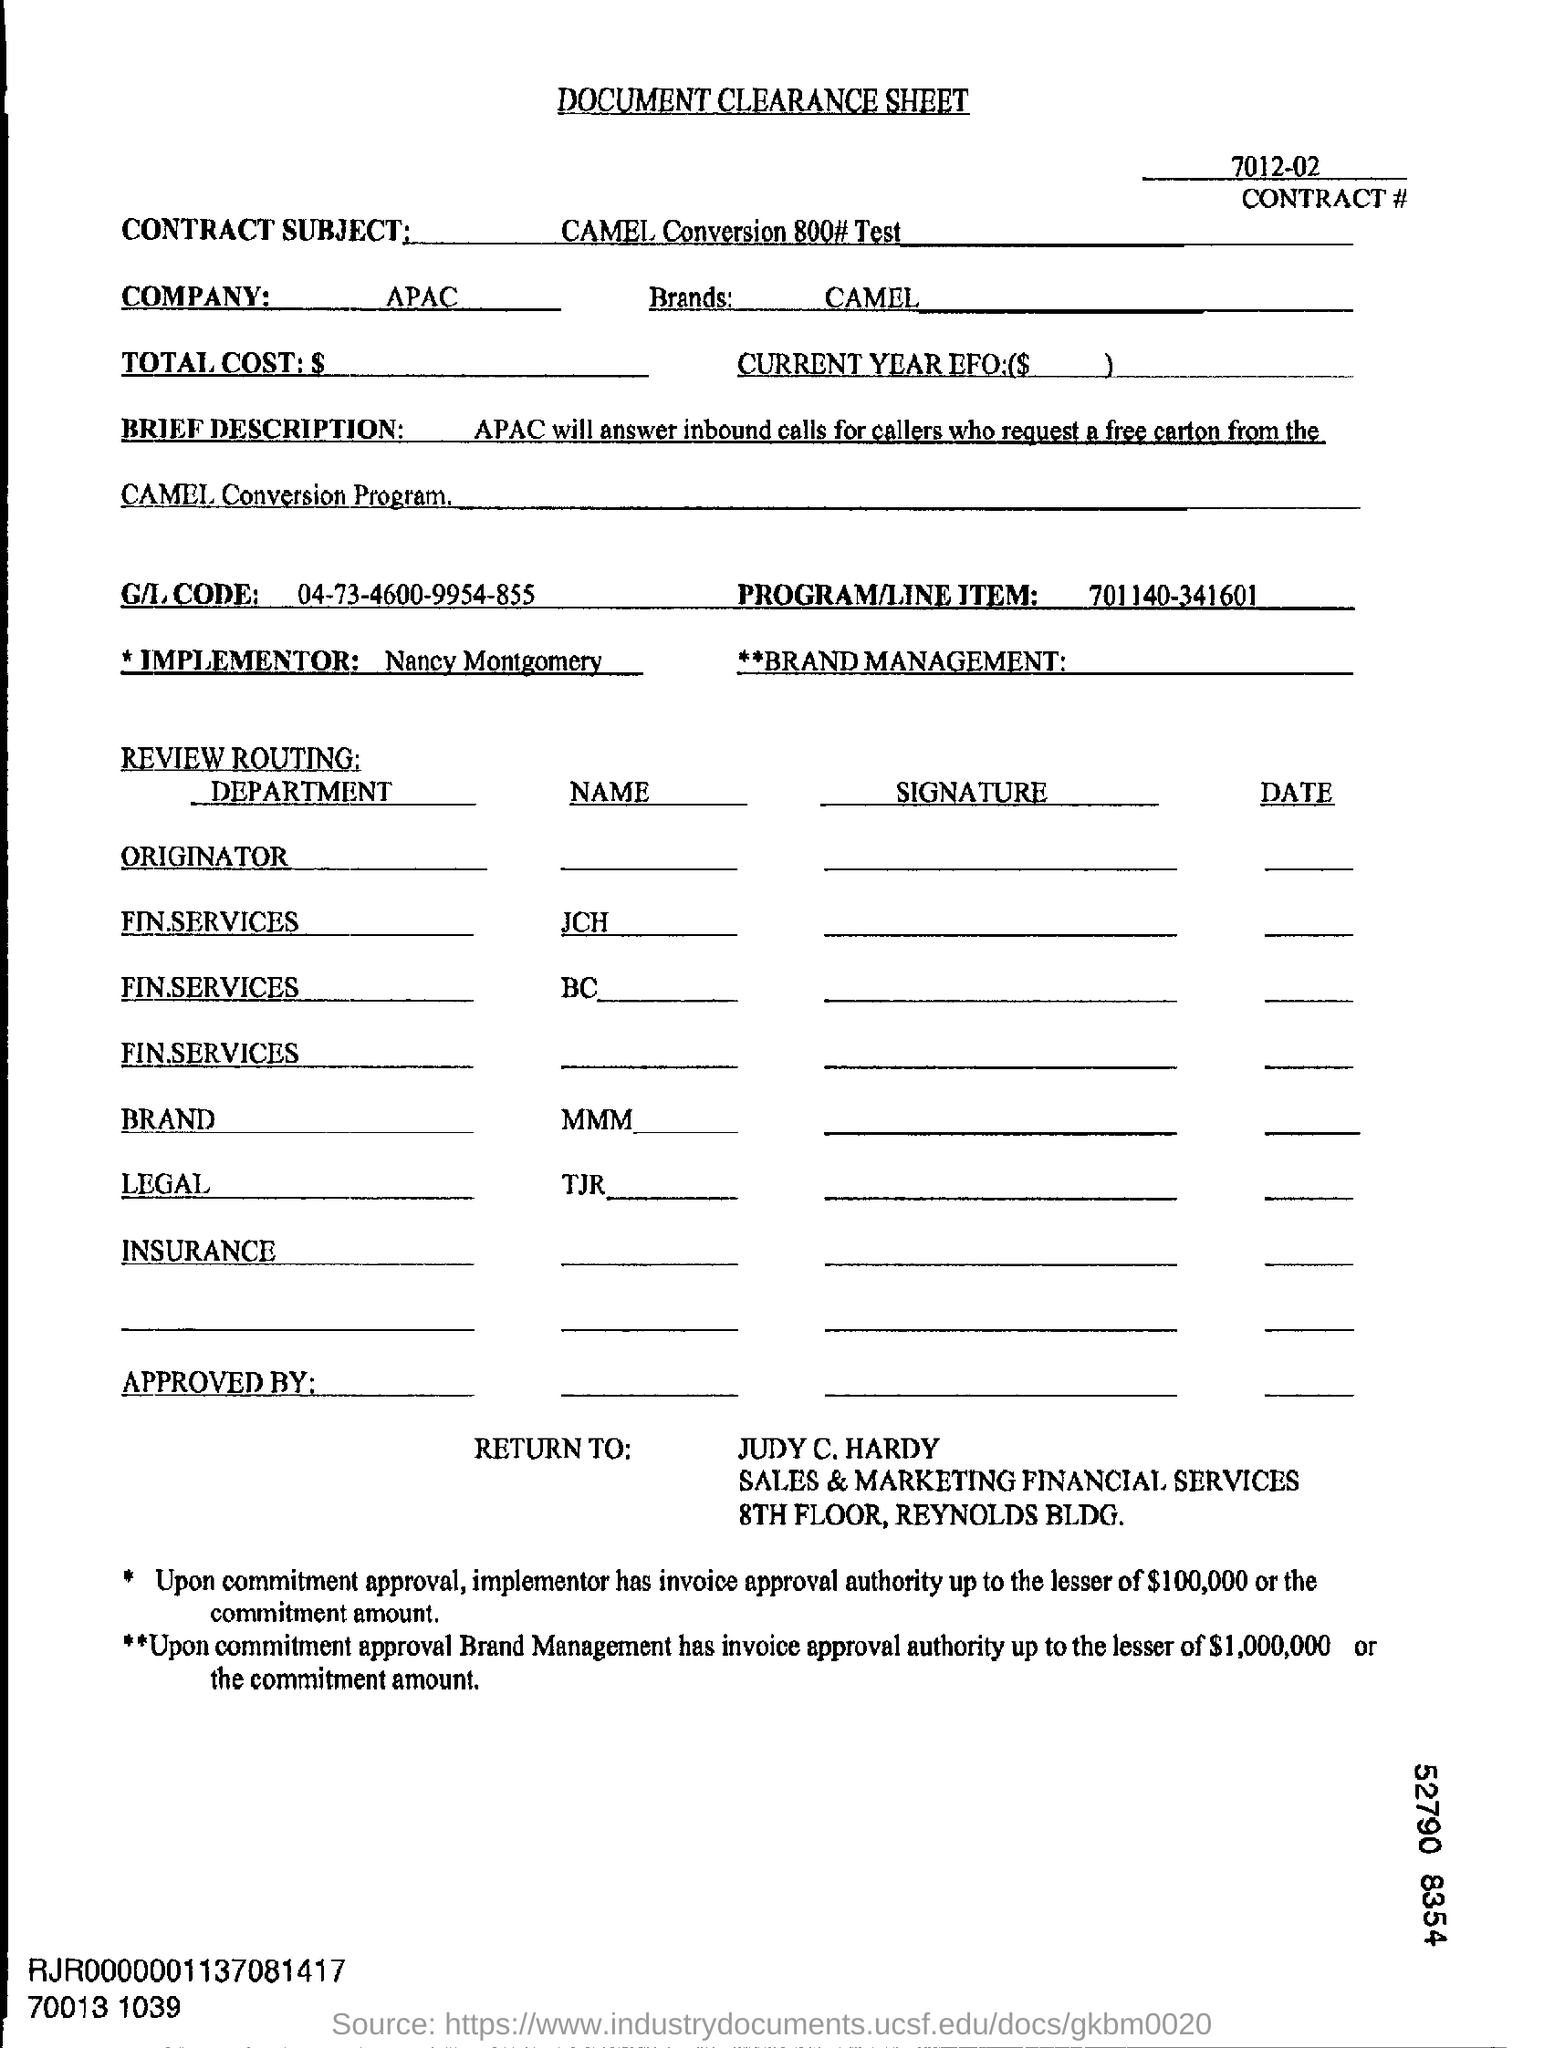What is the sheet name ?
Offer a very short reply. DOCUMENT CLEARANCE SHEET. What is the company name mentioned in the form?
Your answer should be compact. APAC. Which company is this ?
Keep it short and to the point. APAC. What is the Brand name ?
Your answer should be compact. CAMEL. 